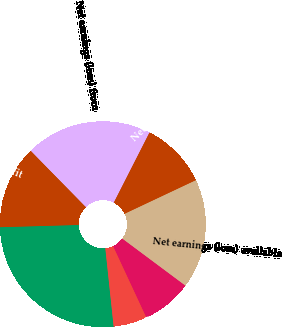<chart> <loc_0><loc_0><loc_500><loc_500><pie_chart><fcel>Net sales<fcel>Gross profit<fcel>Net earnings (loss) from<fcel>Net earnings from discontinued<fcel>Net earnings (loss) available<fcel>Continuing operations<fcel>Discontinued operations<fcel>Net earnings (loss) per common<nl><fcel>26.23%<fcel>13.12%<fcel>19.83%<fcel>10.49%<fcel>17.21%<fcel>7.87%<fcel>0.0%<fcel>5.25%<nl></chart> 